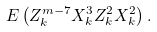<formula> <loc_0><loc_0><loc_500><loc_500>E \left ( Z _ { k } ^ { m - 7 } X _ { k } ^ { 3 } Z _ { k } ^ { 2 } X _ { k } ^ { 2 } \right ) .</formula> 